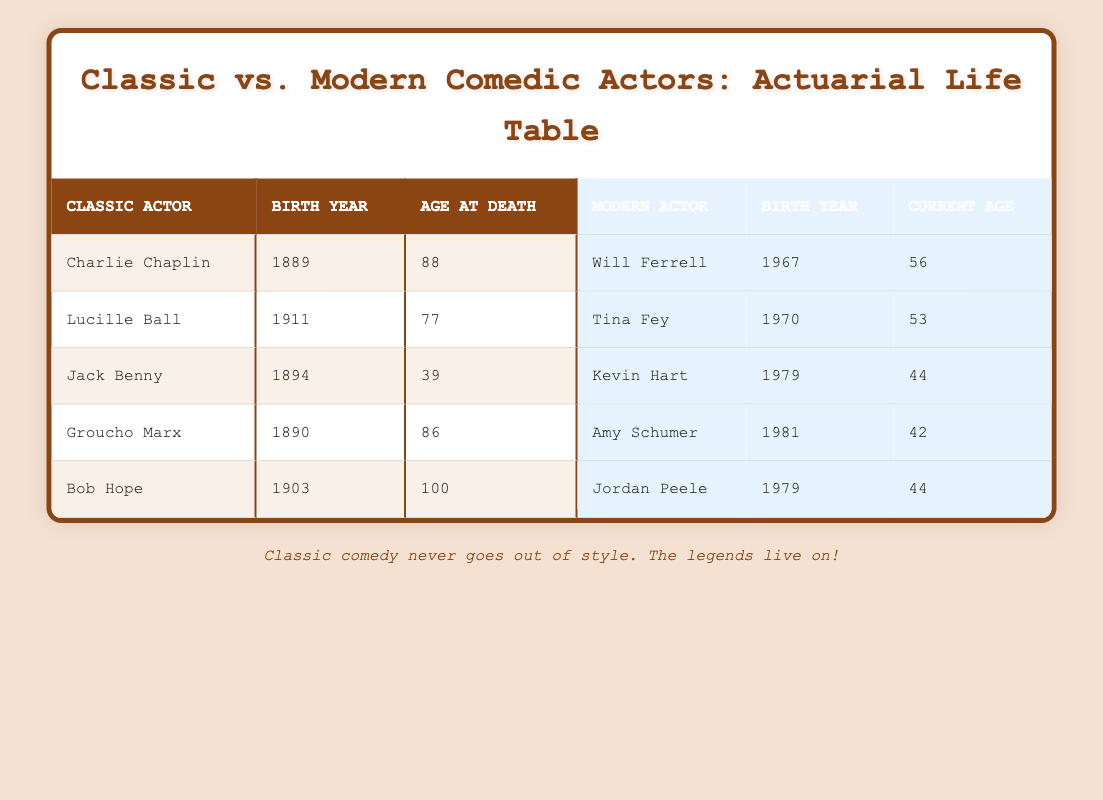What was the age at death of Bob Hope? Bob Hope's age at death is listed as 100 in the table.
Answer: 100 Which classic comedic actor was born in 1911? According to the table, Lucille Ball is the classic comedic actor born in 1911.
Answer: Lucille Ball What is the average current age of modern comedic actors in the table? The current ages of modern actors are 56 (Will Ferrell), 53 (Tina Fey), 44 (Kevin Hart), 42 (Amy Schumer), and 44 (Jordan Peele). Summing these gives 56 + 53 + 44 + 42 + 44 = 239. Dividing by 5 gives an average age of 239/5 = 47.8, which rounds to 48.
Answer: 48 Is it true that all classic comedic actors listed lived to be at least 70 years old? Analyzing the ages at death: Charlie Chaplin (88), Lucille Ball (77), Jack Benny (39), Groucho Marx (86), and Bob Hope (100). Jack Benny did not live to be 70, so the statement is false.
Answer: No Which modern comedic actor is currently the youngest? The current ages are 56, 53, 44, 42, and 44. The youngest among these is Amy Schumer, who is currently 42 years old.
Answer: Amy Schumer What is the difference in age at death between Charlie Chaplin and Groucho Marx? Charlie Chaplin lived to be 88 years old and Groucho Marx lived to be 86 years old. The difference in their ages at death is 88 - 86 = 2 years.
Answer: 2 How many of the classic comedic actors listed lived to be over 80 years old? Reviewing the ages at death: Charlie Chaplin (88), Lucille Ball (77), Jack Benny (39), Groucho Marx (86), and Bob Hope (100). Charlie Chaplin, Groucho Marx, and Bob Hope lived to be over 80, totaling 3 actors.
Answer: 3 What was the birth year of the oldest classic comedic actor? The birth years are: Charlie Chaplin (1889), Lucille Ball (1911), Jack Benny (1894), Groucho Marx (1890), and Bob Hope (1903). The oldest birth year is 1889 for Charlie Chaplin.
Answer: 1889 Which modern comedic actor shares the same birth year as Kevin Hart? The birth year for Kevin Hart is 1979. Upon checking the modern actors, Jordan Peele also has the birth year of 1979.
Answer: Jordan Peele 